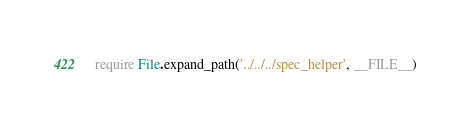<code> <loc_0><loc_0><loc_500><loc_500><_Ruby_>require File.expand_path('../../../spec_helper', __FILE__)</code> 